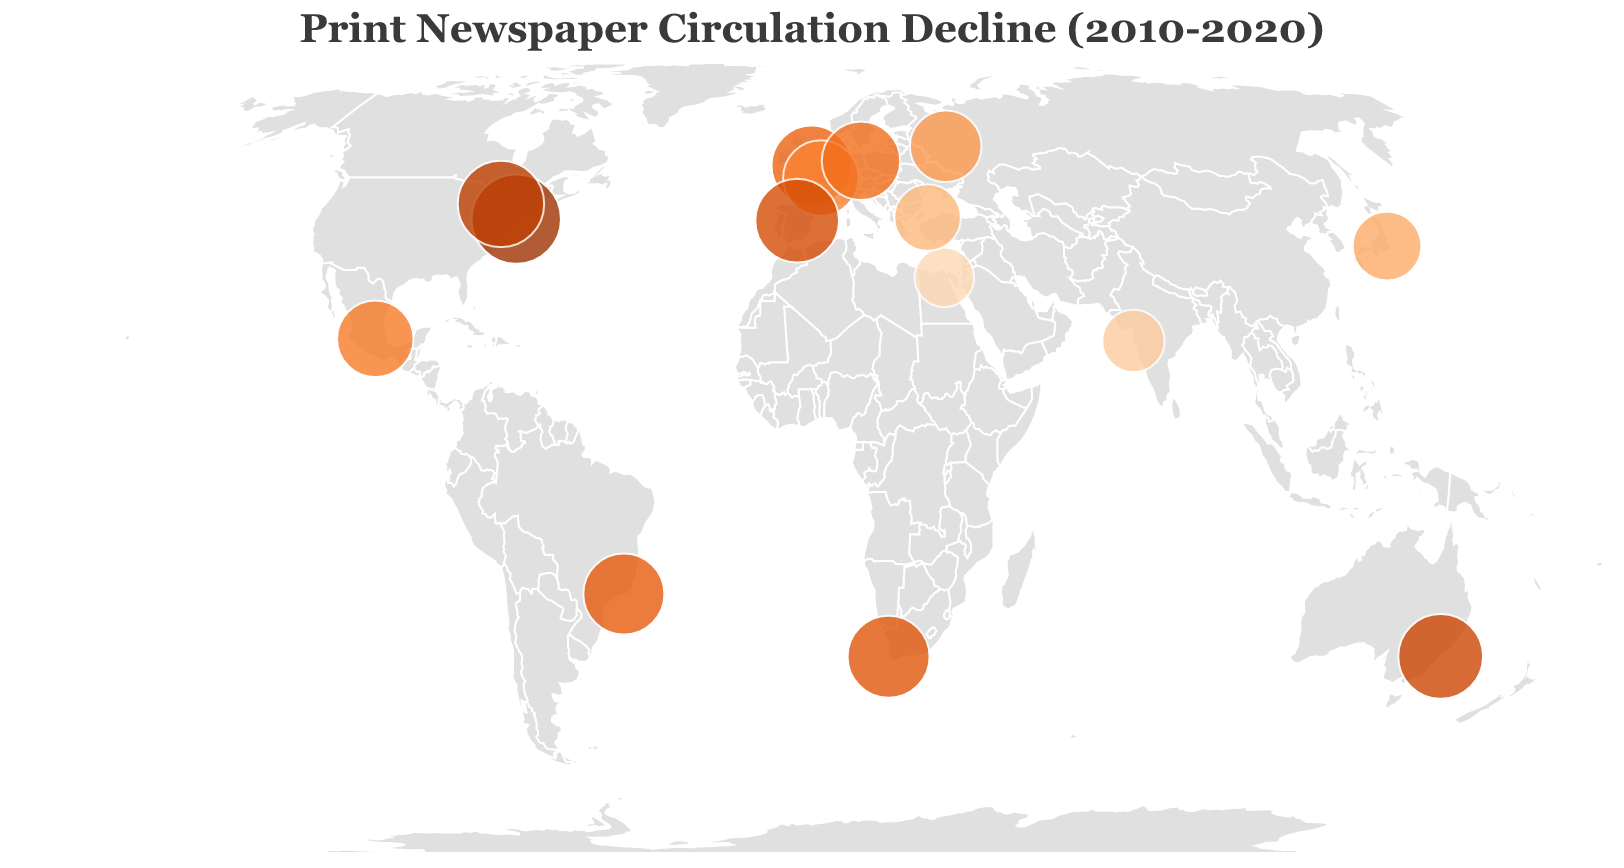What is the title of the figure? The title of the figure is located at the top and is presented in a larger, distinctive font. It states the main topic of the figure.
Answer: "Print Newspaper Circulation Decline (2010-2020)" Which cities have the largest and smallest declines in newspaper circulation? By comparing the circle sizes and colors on the map, the city with the largest decline has the largest, darkest circle, while the city with the smallest decline has the smallest, lightest circle.
Answer: New York (largest), Cairo (smallest) How does the decline in circulation in Sydney compare to that in London? Both cities’ circles need to be observed for their size and color intensity. Sydney’s circle appears larger and darker than London’s, indicating a higher decline.
Answer: Sydney has a higher decline than London Which continents display cities with declines over 50%? By scanning the global map, identify the continents where cities have circles indicating declines above 50%. These cities usually have larger, darker circles.
Answer: North America, Europe, Australia, South America, Africa Are there any cities where the decline in newspaper circulation is below 30%? If so, which ones? The figure shows the cities with circles that are significantly smaller and lighter in color. By examining these, we can identify the cities with declines below 30%.
Answer: Cairo What is the approximate average decline in newspaper circulation across all the listed cities? Sum the declines and divide by the number of cities (15). Calculation: (68.5+54.2+47.8+39.1+61.3+42.7+51.9+59.6+63.8+31.5+28.3+55.7+49.2+57.1+36.4)/15 = 49.08%
Answer: Approximately 49.1% Which city in Asia shows the greatest decline in print newspaper circulation? The figure indicates this by comparing the circle sizes and colors of the Asian cities. The largest circle among them represents the greatest decline.
Answer: Tokyo How do the declines in Toronto and Berlin compare? Observe the figure and compare the sizes and color intensities of the circles representing Toronto and Berlin. Toronto shows a larger, darker circle indicating a higher decline.
Answer: Toronto has a higher decline than Berlin Are there more cities with declines greater than or less than 50%? Categorize the cities based on whether their declines are above or below 50%, then count the numbers in each category.
Answer: More cities have declines greater than 50% In which hemisphere are most of the cities with the highest declines located? By looking at the global map, identify the hemisphere (Northern or Southern) that contains the majority of cities with larger, darker circles indicating high declines.
Answer: Northern Hemisphere 